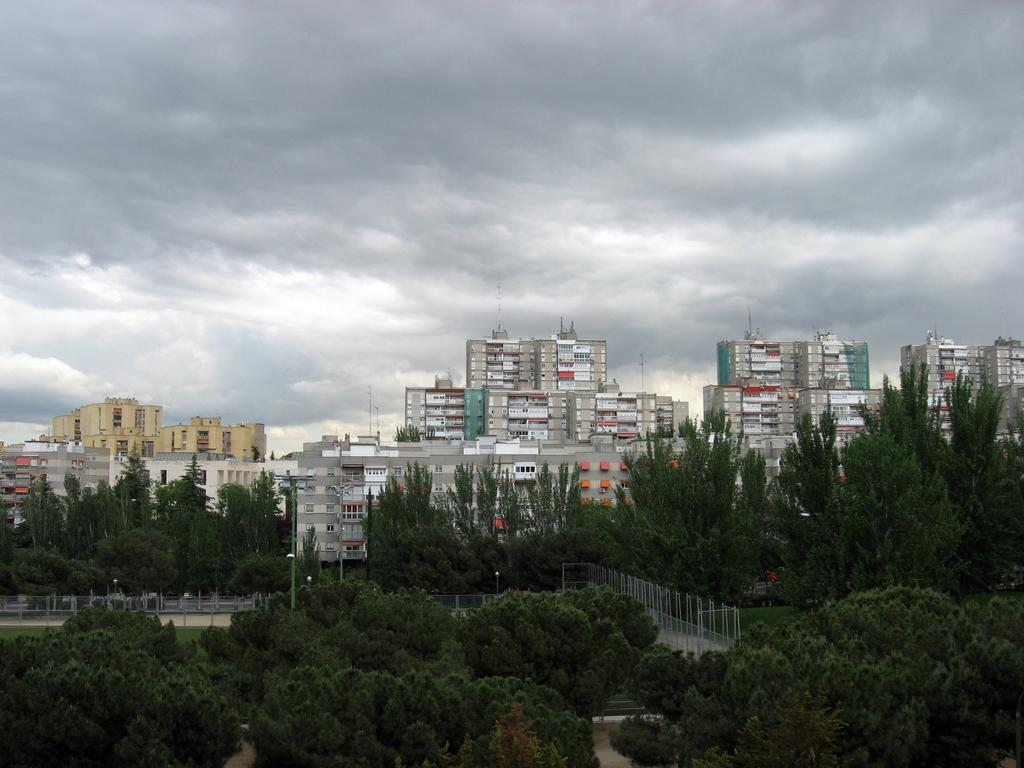What type of vegetation can be seen in the image? There are trees in the image. What structures are present in the image? There are fences and buildings with windows in the image. What are the poles used for in the image? The purpose of the poles is not specified in the image, but they could be used for various purposes such as lighting or signage. What can be seen in the background of the image? The sky with clouds is visible in the background of the image. Can you tell me how many snakes are slithering around the trees in the image? There are no snakes present in the image; it features trees, fences, poles, buildings, and a sky with clouds. What idea is being conveyed by the mass of people in the image? There is no mass of people in the image; it only shows trees, fences, poles, buildings, and a sky with clouds. 